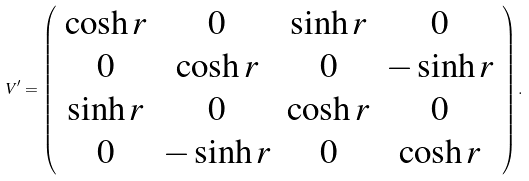Convert formula to latex. <formula><loc_0><loc_0><loc_500><loc_500>V ^ { \prime } = \left ( \begin{array} { c c c c } \cosh r & 0 & \sinh r & 0 \\ 0 & \cosh r & 0 & - \sinh r \\ \sinh r & 0 & \cosh r & 0 \\ 0 & - \sinh r & 0 & \cosh r \end{array} \right ) .</formula> 